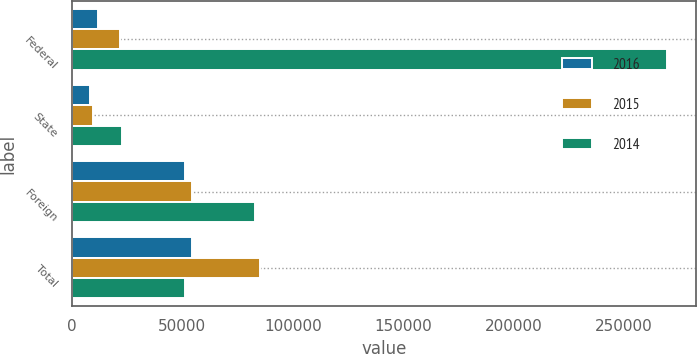Convert chart to OTSL. <chart><loc_0><loc_0><loc_500><loc_500><stacked_bar_chart><ecel><fcel>Federal<fcel>State<fcel>Foreign<fcel>Total<nl><fcel>2016<fcel>11567<fcel>8369<fcel>51189<fcel>54387<nl><fcel>2015<fcel>21719<fcel>9404<fcel>54143<fcel>85266<nl><fcel>2014<fcel>269326<fcel>22835<fcel>82721<fcel>51189<nl></chart> 